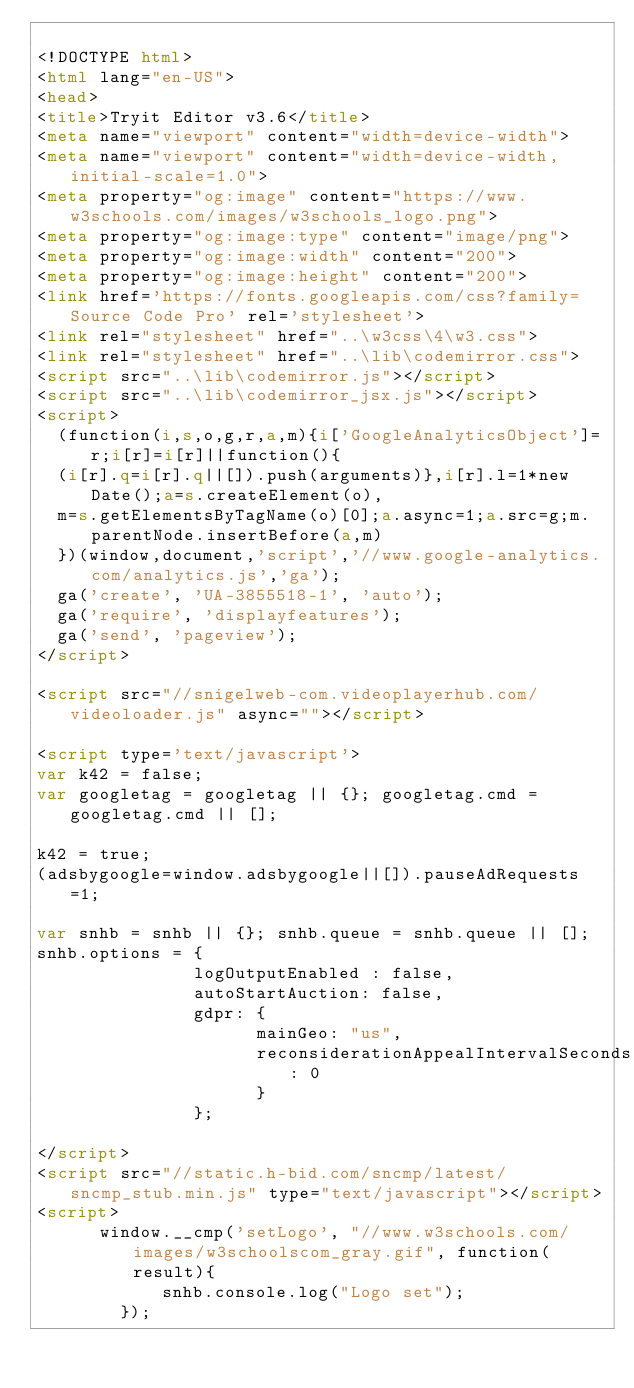<code> <loc_0><loc_0><loc_500><loc_500><_HTML_>
<!DOCTYPE html>
<html lang="en-US">
<head>
<title>Tryit Editor v3.6</title>
<meta name="viewport" content="width=device-width">
<meta name="viewport" content="width=device-width, initial-scale=1.0">
<meta property="og:image" content="https://www.w3schools.com/images/w3schools_logo.png">
<meta property="og:image:type" content="image/png">
<meta property="og:image:width" content="200">
<meta property="og:image:height" content="200">
<link href='https://fonts.googleapis.com/css?family=Source Code Pro' rel='stylesheet'>
<link rel="stylesheet" href="..\w3css\4\w3.css">
<link rel="stylesheet" href="..\lib\codemirror.css">
<script src="..\lib\codemirror.js"></script>
<script src="..\lib\codemirror_jsx.js"></script>
<script>
  (function(i,s,o,g,r,a,m){i['GoogleAnalyticsObject']=r;i[r]=i[r]||function(){
  (i[r].q=i[r].q||[]).push(arguments)},i[r].l=1*new Date();a=s.createElement(o),
  m=s.getElementsByTagName(o)[0];a.async=1;a.src=g;m.parentNode.insertBefore(a,m)
  })(window,document,'script','//www.google-analytics.com/analytics.js','ga');
  ga('create', 'UA-3855518-1', 'auto');
  ga('require', 'displayfeatures');
  ga('send', 'pageview');
</script>

<script src="//snigelweb-com.videoplayerhub.com/videoloader.js" async=""></script>

<script type='text/javascript'>
var k42 = false;
var googletag = googletag || {}; googletag.cmd = googletag.cmd || [];

k42 = true;
(adsbygoogle=window.adsbygoogle||[]).pauseAdRequests=1;

var snhb = snhb || {}; snhb.queue = snhb.queue || [];
snhb.options = {
               logOutputEnabled : false,
               autoStartAuction: false,
               gdpr: {
                     mainGeo: "us",
                     reconsiderationAppealIntervalSeconds: 0
                     }
               };

</script>
<script src="//static.h-bid.com/sncmp/latest/sncmp_stub.min.js" type="text/javascript"></script>
<script>
			window.__cmp('setLogo', "//www.w3schools.com/images/w3schoolscom_gray.gif", function(result){
	       		snhb.console.log("Logo set");
	    	});</code> 